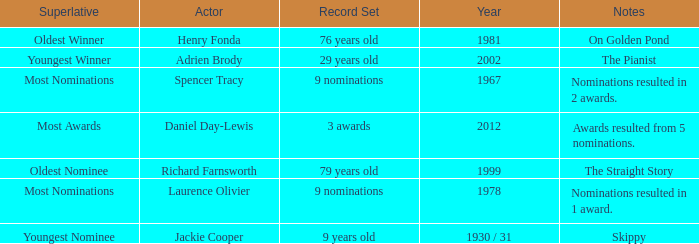What are the notes in 1981? On Golden Pond. 